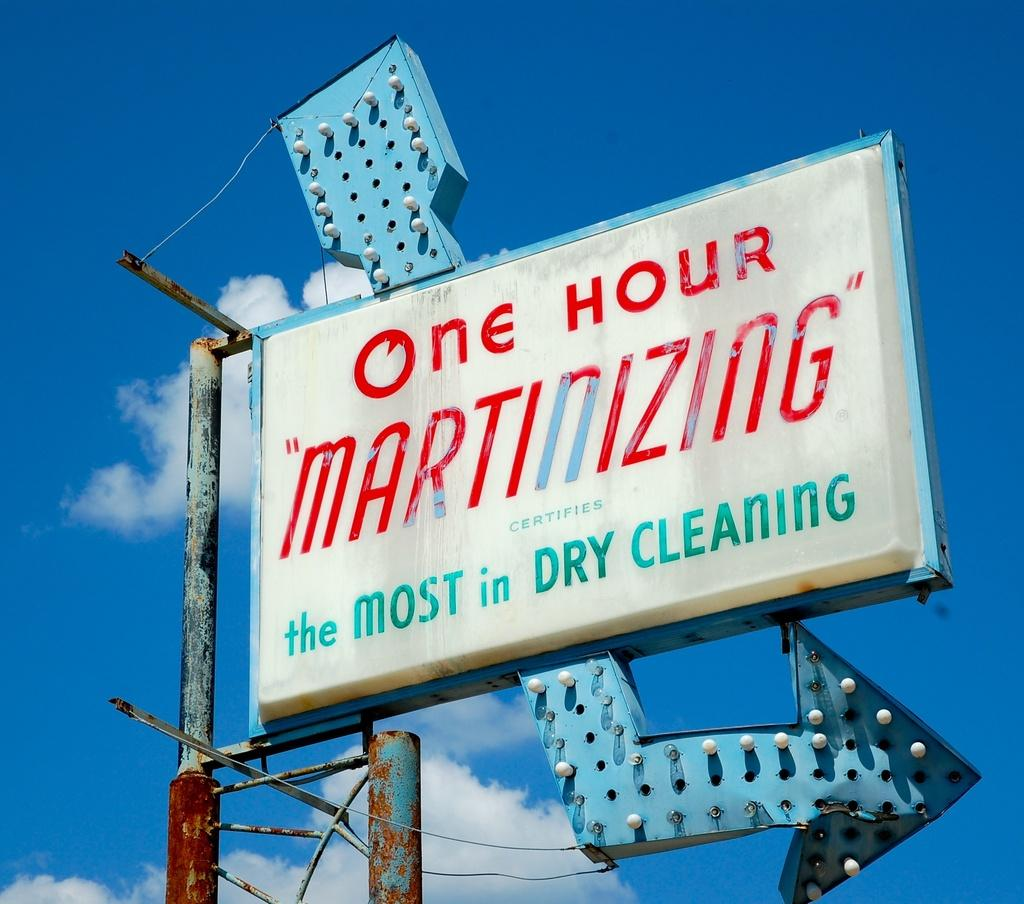<image>
Relay a brief, clear account of the picture shown. A sign for a one hour dry cleaning business. 